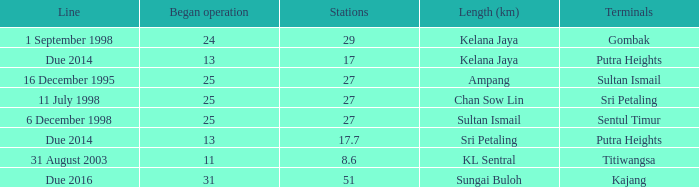What is the typical operation commencing with a length of ampang and across 27 stations? None. 